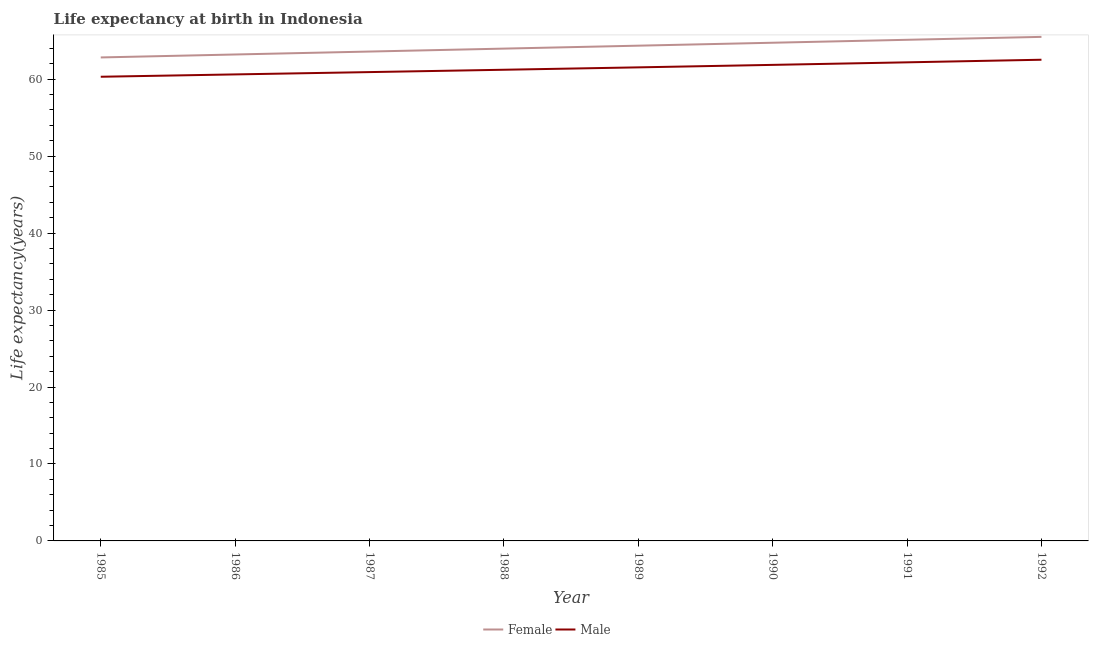Is the number of lines equal to the number of legend labels?
Provide a succinct answer. Yes. What is the life expectancy(male) in 1985?
Provide a short and direct response. 60.31. Across all years, what is the maximum life expectancy(female)?
Keep it short and to the point. 65.5. Across all years, what is the minimum life expectancy(male)?
Provide a short and direct response. 60.31. What is the total life expectancy(female) in the graph?
Give a very brief answer. 513.29. What is the difference between the life expectancy(female) in 1990 and that in 1991?
Offer a very short reply. -0.38. What is the difference between the life expectancy(male) in 1992 and the life expectancy(female) in 1990?
Keep it short and to the point. -2.21. What is the average life expectancy(male) per year?
Offer a terse response. 61.4. In the year 1985, what is the difference between the life expectancy(male) and life expectancy(female)?
Provide a short and direct response. -2.51. In how many years, is the life expectancy(male) greater than 8 years?
Give a very brief answer. 8. What is the ratio of the life expectancy(male) in 1990 to that in 1992?
Your answer should be very brief. 0.99. Is the life expectancy(female) in 1987 less than that in 1990?
Provide a short and direct response. Yes. What is the difference between the highest and the second highest life expectancy(female)?
Ensure brevity in your answer.  0.38. What is the difference between the highest and the lowest life expectancy(male)?
Your answer should be compact. 2.21. In how many years, is the life expectancy(female) greater than the average life expectancy(female) taken over all years?
Provide a short and direct response. 4. Is the sum of the life expectancy(female) in 1987 and 1991 greater than the maximum life expectancy(male) across all years?
Your answer should be very brief. Yes. Does the life expectancy(male) monotonically increase over the years?
Give a very brief answer. Yes. Is the life expectancy(female) strictly greater than the life expectancy(male) over the years?
Make the answer very short. Yes. Is the life expectancy(male) strictly less than the life expectancy(female) over the years?
Your answer should be very brief. Yes. How many years are there in the graph?
Your answer should be very brief. 8. What is the difference between two consecutive major ticks on the Y-axis?
Your answer should be very brief. 10. Are the values on the major ticks of Y-axis written in scientific E-notation?
Offer a very short reply. No. Does the graph contain grids?
Make the answer very short. No. How many legend labels are there?
Give a very brief answer. 2. How are the legend labels stacked?
Offer a terse response. Horizontal. What is the title of the graph?
Give a very brief answer. Life expectancy at birth in Indonesia. What is the label or title of the Y-axis?
Your answer should be compact. Life expectancy(years). What is the Life expectancy(years) of Female in 1985?
Offer a terse response. 62.82. What is the Life expectancy(years) in Male in 1985?
Keep it short and to the point. 60.31. What is the Life expectancy(years) in Female in 1986?
Your response must be concise. 63.21. What is the Life expectancy(years) of Male in 1986?
Make the answer very short. 60.62. What is the Life expectancy(years) in Female in 1987?
Provide a succinct answer. 63.59. What is the Life expectancy(years) of Male in 1987?
Provide a succinct answer. 60.92. What is the Life expectancy(years) in Female in 1988?
Ensure brevity in your answer.  63.97. What is the Life expectancy(years) in Male in 1988?
Provide a short and direct response. 61.22. What is the Life expectancy(years) of Female in 1989?
Ensure brevity in your answer.  64.35. What is the Life expectancy(years) in Male in 1989?
Offer a very short reply. 61.53. What is the Life expectancy(years) in Female in 1990?
Give a very brief answer. 64.73. What is the Life expectancy(years) of Male in 1990?
Your response must be concise. 61.86. What is the Life expectancy(years) in Female in 1991?
Offer a terse response. 65.12. What is the Life expectancy(years) in Male in 1991?
Ensure brevity in your answer.  62.19. What is the Life expectancy(years) in Female in 1992?
Your answer should be very brief. 65.5. What is the Life expectancy(years) in Male in 1992?
Your answer should be very brief. 62.52. Across all years, what is the maximum Life expectancy(years) of Female?
Provide a short and direct response. 65.5. Across all years, what is the maximum Life expectancy(years) in Male?
Your answer should be very brief. 62.52. Across all years, what is the minimum Life expectancy(years) of Female?
Your response must be concise. 62.82. Across all years, what is the minimum Life expectancy(years) in Male?
Make the answer very short. 60.31. What is the total Life expectancy(years) of Female in the graph?
Make the answer very short. 513.29. What is the total Life expectancy(years) of Male in the graph?
Give a very brief answer. 491.18. What is the difference between the Life expectancy(years) of Female in 1985 and that in 1986?
Your answer should be very brief. -0.38. What is the difference between the Life expectancy(years) of Male in 1985 and that in 1986?
Your answer should be very brief. -0.3. What is the difference between the Life expectancy(years) in Female in 1985 and that in 1987?
Provide a succinct answer. -0.77. What is the difference between the Life expectancy(years) of Male in 1985 and that in 1987?
Ensure brevity in your answer.  -0.6. What is the difference between the Life expectancy(years) of Female in 1985 and that in 1988?
Offer a terse response. -1.15. What is the difference between the Life expectancy(years) in Male in 1985 and that in 1988?
Offer a terse response. -0.91. What is the difference between the Life expectancy(years) of Female in 1985 and that in 1989?
Ensure brevity in your answer.  -1.53. What is the difference between the Life expectancy(years) in Male in 1985 and that in 1989?
Offer a very short reply. -1.22. What is the difference between the Life expectancy(years) of Female in 1985 and that in 1990?
Keep it short and to the point. -1.91. What is the difference between the Life expectancy(years) in Male in 1985 and that in 1990?
Ensure brevity in your answer.  -1.54. What is the difference between the Life expectancy(years) in Female in 1985 and that in 1991?
Give a very brief answer. -2.29. What is the difference between the Life expectancy(years) in Male in 1985 and that in 1991?
Provide a succinct answer. -1.87. What is the difference between the Life expectancy(years) in Female in 1985 and that in 1992?
Make the answer very short. -2.67. What is the difference between the Life expectancy(years) in Male in 1985 and that in 1992?
Keep it short and to the point. -2.21. What is the difference between the Life expectancy(years) in Female in 1986 and that in 1987?
Ensure brevity in your answer.  -0.38. What is the difference between the Life expectancy(years) in Male in 1986 and that in 1987?
Your answer should be compact. -0.3. What is the difference between the Life expectancy(years) of Female in 1986 and that in 1988?
Give a very brief answer. -0.76. What is the difference between the Life expectancy(years) of Male in 1986 and that in 1988?
Provide a short and direct response. -0.6. What is the difference between the Life expectancy(years) of Female in 1986 and that in 1989?
Give a very brief answer. -1.14. What is the difference between the Life expectancy(years) of Male in 1986 and that in 1989?
Provide a short and direct response. -0.92. What is the difference between the Life expectancy(years) of Female in 1986 and that in 1990?
Make the answer very short. -1.53. What is the difference between the Life expectancy(years) in Male in 1986 and that in 1990?
Your response must be concise. -1.24. What is the difference between the Life expectancy(years) in Female in 1986 and that in 1991?
Offer a terse response. -1.91. What is the difference between the Life expectancy(years) in Male in 1986 and that in 1991?
Keep it short and to the point. -1.57. What is the difference between the Life expectancy(years) of Female in 1986 and that in 1992?
Provide a short and direct response. -2.29. What is the difference between the Life expectancy(years) in Male in 1986 and that in 1992?
Provide a succinct answer. -1.91. What is the difference between the Life expectancy(years) of Female in 1987 and that in 1988?
Ensure brevity in your answer.  -0.38. What is the difference between the Life expectancy(years) of Male in 1987 and that in 1988?
Provide a short and direct response. -0.3. What is the difference between the Life expectancy(years) of Female in 1987 and that in 1989?
Ensure brevity in your answer.  -0.76. What is the difference between the Life expectancy(years) in Male in 1987 and that in 1989?
Offer a very short reply. -0.61. What is the difference between the Life expectancy(years) in Female in 1987 and that in 1990?
Offer a terse response. -1.15. What is the difference between the Life expectancy(years) in Male in 1987 and that in 1990?
Keep it short and to the point. -0.94. What is the difference between the Life expectancy(years) of Female in 1987 and that in 1991?
Your answer should be compact. -1.53. What is the difference between the Life expectancy(years) in Male in 1987 and that in 1991?
Offer a very short reply. -1.27. What is the difference between the Life expectancy(years) in Female in 1987 and that in 1992?
Provide a short and direct response. -1.91. What is the difference between the Life expectancy(years) in Male in 1987 and that in 1992?
Provide a short and direct response. -1.61. What is the difference between the Life expectancy(years) of Female in 1988 and that in 1989?
Your answer should be very brief. -0.38. What is the difference between the Life expectancy(years) of Male in 1988 and that in 1989?
Provide a succinct answer. -0.31. What is the difference between the Life expectancy(years) in Female in 1988 and that in 1990?
Keep it short and to the point. -0.76. What is the difference between the Life expectancy(years) of Male in 1988 and that in 1990?
Offer a very short reply. -0.63. What is the difference between the Life expectancy(years) of Female in 1988 and that in 1991?
Your answer should be compact. -1.15. What is the difference between the Life expectancy(years) of Male in 1988 and that in 1991?
Ensure brevity in your answer.  -0.96. What is the difference between the Life expectancy(years) in Female in 1988 and that in 1992?
Your response must be concise. -1.52. What is the difference between the Life expectancy(years) of Male in 1988 and that in 1992?
Give a very brief answer. -1.3. What is the difference between the Life expectancy(years) of Female in 1989 and that in 1990?
Your response must be concise. -0.38. What is the difference between the Life expectancy(years) of Male in 1989 and that in 1990?
Provide a short and direct response. -0.32. What is the difference between the Life expectancy(years) in Female in 1989 and that in 1991?
Your answer should be very brief. -0.76. What is the difference between the Life expectancy(years) of Male in 1989 and that in 1991?
Offer a very short reply. -0.65. What is the difference between the Life expectancy(years) in Female in 1989 and that in 1992?
Offer a terse response. -1.14. What is the difference between the Life expectancy(years) in Male in 1989 and that in 1992?
Offer a very short reply. -0.99. What is the difference between the Life expectancy(years) in Female in 1990 and that in 1991?
Provide a short and direct response. -0.38. What is the difference between the Life expectancy(years) of Male in 1990 and that in 1991?
Provide a succinct answer. -0.33. What is the difference between the Life expectancy(years) of Female in 1990 and that in 1992?
Your answer should be very brief. -0.76. What is the difference between the Life expectancy(years) of Male in 1990 and that in 1992?
Give a very brief answer. -0.67. What is the difference between the Life expectancy(years) of Female in 1991 and that in 1992?
Your response must be concise. -0.38. What is the difference between the Life expectancy(years) of Male in 1991 and that in 1992?
Your response must be concise. -0.34. What is the difference between the Life expectancy(years) in Female in 1985 and the Life expectancy(years) in Male in 1986?
Ensure brevity in your answer.  2.21. What is the difference between the Life expectancy(years) in Female in 1985 and the Life expectancy(years) in Male in 1987?
Give a very brief answer. 1.91. What is the difference between the Life expectancy(years) of Female in 1985 and the Life expectancy(years) of Male in 1988?
Ensure brevity in your answer.  1.6. What is the difference between the Life expectancy(years) in Female in 1985 and the Life expectancy(years) in Male in 1989?
Provide a short and direct response. 1.29. What is the difference between the Life expectancy(years) in Female in 1985 and the Life expectancy(years) in Male in 1991?
Keep it short and to the point. 0.64. What is the difference between the Life expectancy(years) in Female in 1985 and the Life expectancy(years) in Male in 1992?
Your response must be concise. 0.3. What is the difference between the Life expectancy(years) in Female in 1986 and the Life expectancy(years) in Male in 1987?
Your answer should be compact. 2.29. What is the difference between the Life expectancy(years) in Female in 1986 and the Life expectancy(years) in Male in 1988?
Your answer should be compact. 1.99. What is the difference between the Life expectancy(years) in Female in 1986 and the Life expectancy(years) in Male in 1989?
Give a very brief answer. 1.67. What is the difference between the Life expectancy(years) in Female in 1986 and the Life expectancy(years) in Male in 1990?
Your answer should be compact. 1.35. What is the difference between the Life expectancy(years) of Female in 1986 and the Life expectancy(years) of Male in 1992?
Offer a very short reply. 0.68. What is the difference between the Life expectancy(years) in Female in 1987 and the Life expectancy(years) in Male in 1988?
Your answer should be compact. 2.37. What is the difference between the Life expectancy(years) of Female in 1987 and the Life expectancy(years) of Male in 1989?
Give a very brief answer. 2.06. What is the difference between the Life expectancy(years) of Female in 1987 and the Life expectancy(years) of Male in 1990?
Offer a terse response. 1.73. What is the difference between the Life expectancy(years) of Female in 1987 and the Life expectancy(years) of Male in 1991?
Give a very brief answer. 1.4. What is the difference between the Life expectancy(years) of Female in 1987 and the Life expectancy(years) of Male in 1992?
Offer a very short reply. 1.06. What is the difference between the Life expectancy(years) in Female in 1988 and the Life expectancy(years) in Male in 1989?
Your answer should be compact. 2.44. What is the difference between the Life expectancy(years) of Female in 1988 and the Life expectancy(years) of Male in 1990?
Offer a terse response. 2.12. What is the difference between the Life expectancy(years) of Female in 1988 and the Life expectancy(years) of Male in 1991?
Your answer should be very brief. 1.78. What is the difference between the Life expectancy(years) in Female in 1988 and the Life expectancy(years) in Male in 1992?
Ensure brevity in your answer.  1.45. What is the difference between the Life expectancy(years) in Female in 1989 and the Life expectancy(years) in Male in 1990?
Keep it short and to the point. 2.5. What is the difference between the Life expectancy(years) of Female in 1989 and the Life expectancy(years) of Male in 1991?
Provide a succinct answer. 2.16. What is the difference between the Life expectancy(years) of Female in 1989 and the Life expectancy(years) of Male in 1992?
Give a very brief answer. 1.83. What is the difference between the Life expectancy(years) in Female in 1990 and the Life expectancy(years) in Male in 1991?
Provide a succinct answer. 2.55. What is the difference between the Life expectancy(years) in Female in 1990 and the Life expectancy(years) in Male in 1992?
Provide a short and direct response. 2.21. What is the difference between the Life expectancy(years) in Female in 1991 and the Life expectancy(years) in Male in 1992?
Give a very brief answer. 2.59. What is the average Life expectancy(years) of Female per year?
Provide a short and direct response. 64.16. What is the average Life expectancy(years) in Male per year?
Give a very brief answer. 61.4. In the year 1985, what is the difference between the Life expectancy(years) of Female and Life expectancy(years) of Male?
Offer a terse response. 2.51. In the year 1986, what is the difference between the Life expectancy(years) of Female and Life expectancy(years) of Male?
Your response must be concise. 2.59. In the year 1987, what is the difference between the Life expectancy(years) of Female and Life expectancy(years) of Male?
Keep it short and to the point. 2.67. In the year 1988, what is the difference between the Life expectancy(years) in Female and Life expectancy(years) in Male?
Ensure brevity in your answer.  2.75. In the year 1989, what is the difference between the Life expectancy(years) in Female and Life expectancy(years) in Male?
Offer a terse response. 2.82. In the year 1990, what is the difference between the Life expectancy(years) of Female and Life expectancy(years) of Male?
Give a very brief answer. 2.88. In the year 1991, what is the difference between the Life expectancy(years) in Female and Life expectancy(years) in Male?
Make the answer very short. 2.93. In the year 1992, what is the difference between the Life expectancy(years) in Female and Life expectancy(years) in Male?
Your answer should be compact. 2.97. What is the ratio of the Life expectancy(years) in Female in 1985 to that in 1986?
Your answer should be compact. 0.99. What is the ratio of the Life expectancy(years) in Female in 1985 to that in 1988?
Your answer should be compact. 0.98. What is the ratio of the Life expectancy(years) of Male in 1985 to that in 1988?
Make the answer very short. 0.99. What is the ratio of the Life expectancy(years) in Female in 1985 to that in 1989?
Ensure brevity in your answer.  0.98. What is the ratio of the Life expectancy(years) of Male in 1985 to that in 1989?
Provide a succinct answer. 0.98. What is the ratio of the Life expectancy(years) in Female in 1985 to that in 1990?
Provide a short and direct response. 0.97. What is the ratio of the Life expectancy(years) of Male in 1985 to that in 1990?
Give a very brief answer. 0.98. What is the ratio of the Life expectancy(years) in Female in 1985 to that in 1991?
Provide a succinct answer. 0.96. What is the ratio of the Life expectancy(years) in Male in 1985 to that in 1991?
Provide a short and direct response. 0.97. What is the ratio of the Life expectancy(years) in Female in 1985 to that in 1992?
Make the answer very short. 0.96. What is the ratio of the Life expectancy(years) of Male in 1985 to that in 1992?
Your response must be concise. 0.96. What is the ratio of the Life expectancy(years) of Male in 1986 to that in 1987?
Ensure brevity in your answer.  1. What is the ratio of the Life expectancy(years) of Female in 1986 to that in 1989?
Your answer should be very brief. 0.98. What is the ratio of the Life expectancy(years) of Male in 1986 to that in 1989?
Ensure brevity in your answer.  0.99. What is the ratio of the Life expectancy(years) of Female in 1986 to that in 1990?
Give a very brief answer. 0.98. What is the ratio of the Life expectancy(years) in Male in 1986 to that in 1990?
Give a very brief answer. 0.98. What is the ratio of the Life expectancy(years) in Female in 1986 to that in 1991?
Provide a succinct answer. 0.97. What is the ratio of the Life expectancy(years) in Male in 1986 to that in 1991?
Your response must be concise. 0.97. What is the ratio of the Life expectancy(years) of Female in 1986 to that in 1992?
Make the answer very short. 0.97. What is the ratio of the Life expectancy(years) of Male in 1986 to that in 1992?
Your response must be concise. 0.97. What is the ratio of the Life expectancy(years) of Female in 1987 to that in 1988?
Make the answer very short. 0.99. What is the ratio of the Life expectancy(years) in Male in 1987 to that in 1989?
Your response must be concise. 0.99. What is the ratio of the Life expectancy(years) in Female in 1987 to that in 1990?
Provide a short and direct response. 0.98. What is the ratio of the Life expectancy(years) in Male in 1987 to that in 1990?
Keep it short and to the point. 0.98. What is the ratio of the Life expectancy(years) in Female in 1987 to that in 1991?
Your response must be concise. 0.98. What is the ratio of the Life expectancy(years) of Male in 1987 to that in 1991?
Provide a short and direct response. 0.98. What is the ratio of the Life expectancy(years) in Female in 1987 to that in 1992?
Ensure brevity in your answer.  0.97. What is the ratio of the Life expectancy(years) in Male in 1987 to that in 1992?
Your answer should be very brief. 0.97. What is the ratio of the Life expectancy(years) of Female in 1988 to that in 1989?
Make the answer very short. 0.99. What is the ratio of the Life expectancy(years) in Male in 1988 to that in 1989?
Offer a very short reply. 0.99. What is the ratio of the Life expectancy(years) of Female in 1988 to that in 1991?
Give a very brief answer. 0.98. What is the ratio of the Life expectancy(years) in Male in 1988 to that in 1991?
Provide a succinct answer. 0.98. What is the ratio of the Life expectancy(years) of Female in 1988 to that in 1992?
Offer a terse response. 0.98. What is the ratio of the Life expectancy(years) in Male in 1988 to that in 1992?
Your answer should be very brief. 0.98. What is the ratio of the Life expectancy(years) of Female in 1989 to that in 1990?
Make the answer very short. 0.99. What is the ratio of the Life expectancy(years) in Male in 1989 to that in 1990?
Make the answer very short. 0.99. What is the ratio of the Life expectancy(years) of Female in 1989 to that in 1991?
Give a very brief answer. 0.99. What is the ratio of the Life expectancy(years) in Female in 1989 to that in 1992?
Offer a terse response. 0.98. What is the ratio of the Life expectancy(years) in Male in 1989 to that in 1992?
Provide a short and direct response. 0.98. What is the ratio of the Life expectancy(years) of Female in 1990 to that in 1992?
Provide a short and direct response. 0.99. What is the ratio of the Life expectancy(years) of Male in 1990 to that in 1992?
Provide a short and direct response. 0.99. What is the ratio of the Life expectancy(years) of Female in 1991 to that in 1992?
Ensure brevity in your answer.  0.99. What is the ratio of the Life expectancy(years) of Male in 1991 to that in 1992?
Make the answer very short. 0.99. What is the difference between the highest and the second highest Life expectancy(years) in Female?
Your response must be concise. 0.38. What is the difference between the highest and the second highest Life expectancy(years) of Male?
Make the answer very short. 0.34. What is the difference between the highest and the lowest Life expectancy(years) in Female?
Make the answer very short. 2.67. What is the difference between the highest and the lowest Life expectancy(years) in Male?
Ensure brevity in your answer.  2.21. 